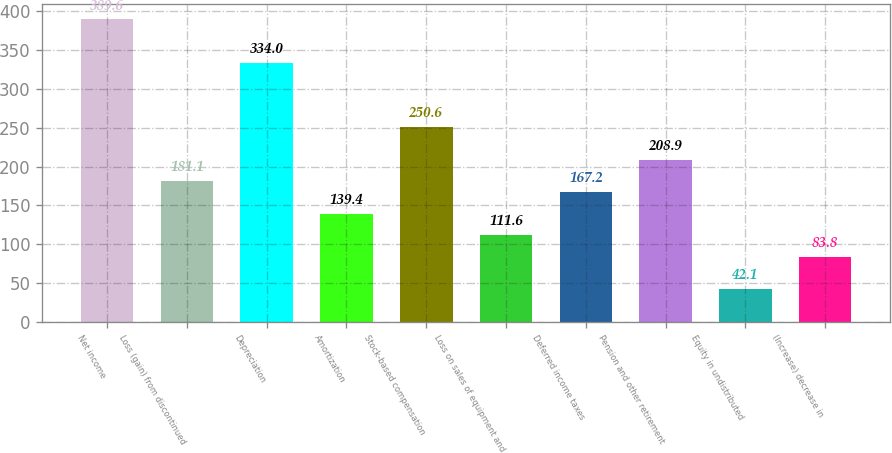Convert chart. <chart><loc_0><loc_0><loc_500><loc_500><bar_chart><fcel>Net income<fcel>Loss (gain) from discontinued<fcel>Depreciation<fcel>Amortization<fcel>Stock-based compensation<fcel>Loss on sales of equipment and<fcel>Deferred income taxes<fcel>Pension and other retirement<fcel>Equity in undistributed<fcel>(Increase) decrease in<nl><fcel>389.6<fcel>181.1<fcel>334<fcel>139.4<fcel>250.6<fcel>111.6<fcel>167.2<fcel>208.9<fcel>42.1<fcel>83.8<nl></chart> 